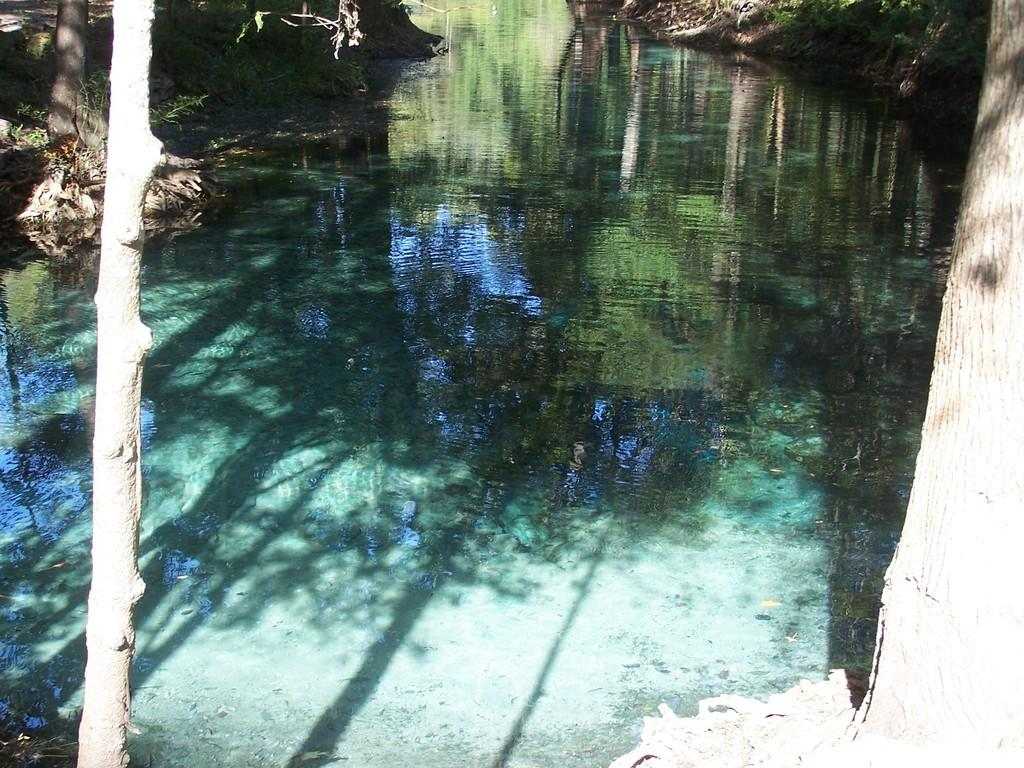What is the main feature in the center of the image? There is water in the center of the image. What type of vegetation can be seen on the left side of the image? Trees are present on the left side of the image. What type of vegetation can be seen on the right side of the image? Trees are present on the right side of the image. What type of ground cover is present on the left side of the image? Grass is present on the left side of the image. What type of ground cover is present on the right side of the image? Grass is present on the right side of the image. Can you describe the ground visible in the top left corner of the image? The ground is visible in the top left corner of the image. What type of cord is hanging from the trees in the image? There is no cord visible in the image; only trees, grass, and water are present. 